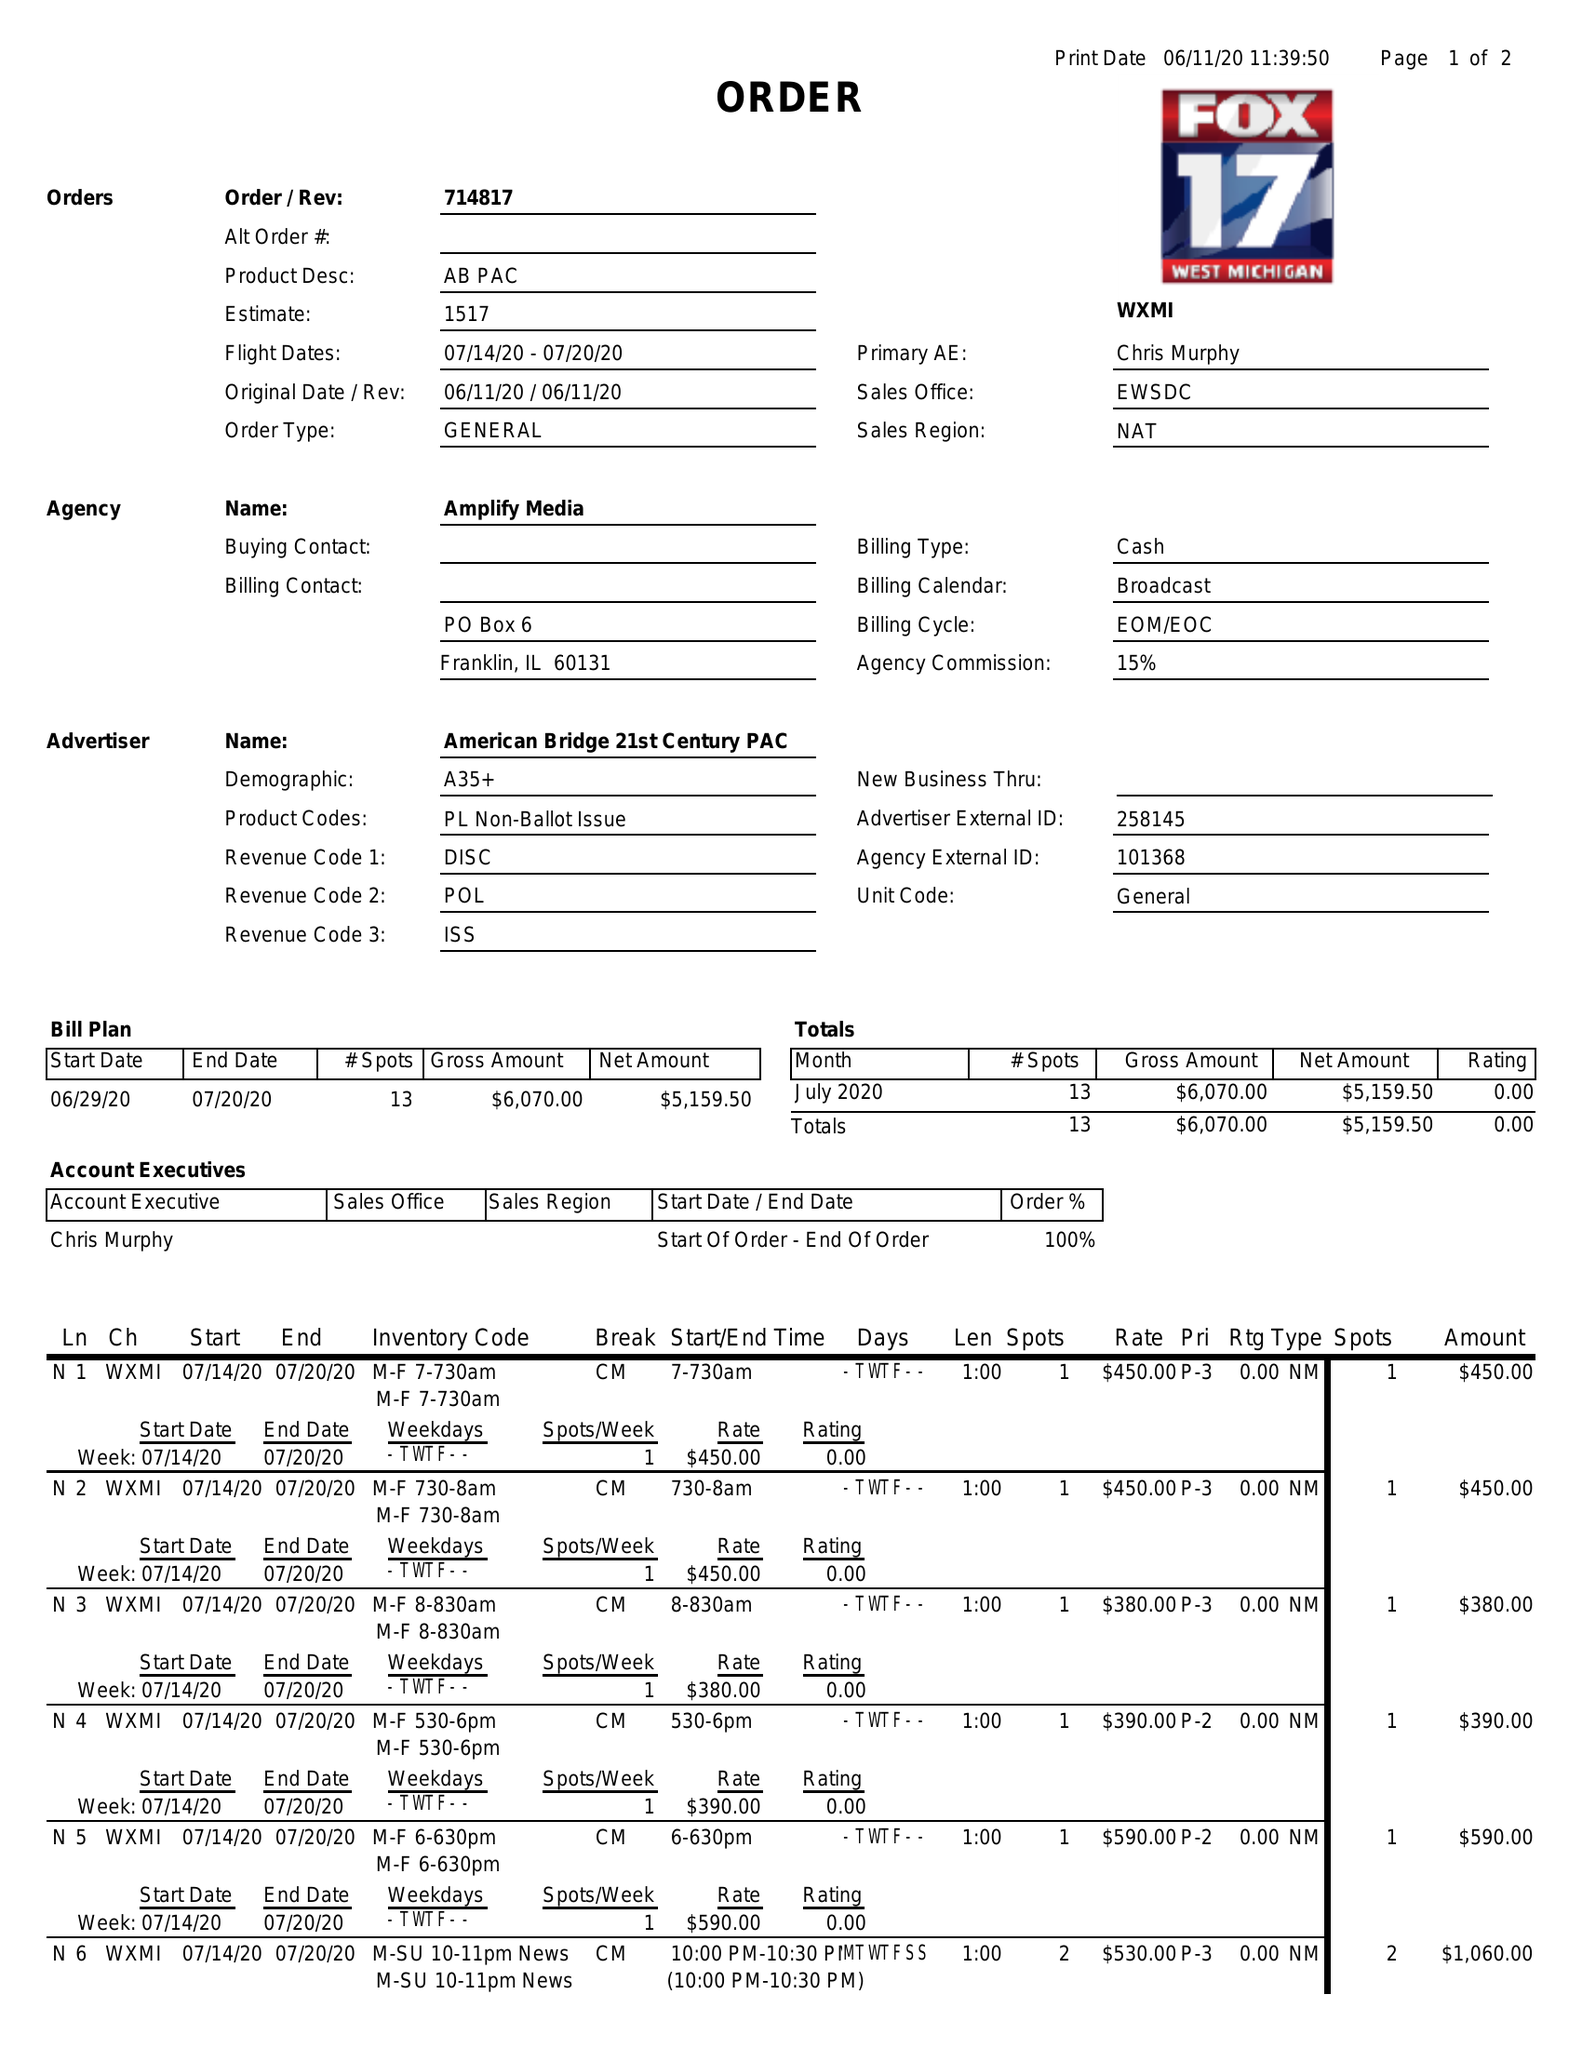What is the value for the contract_num?
Answer the question using a single word or phrase. 714817 